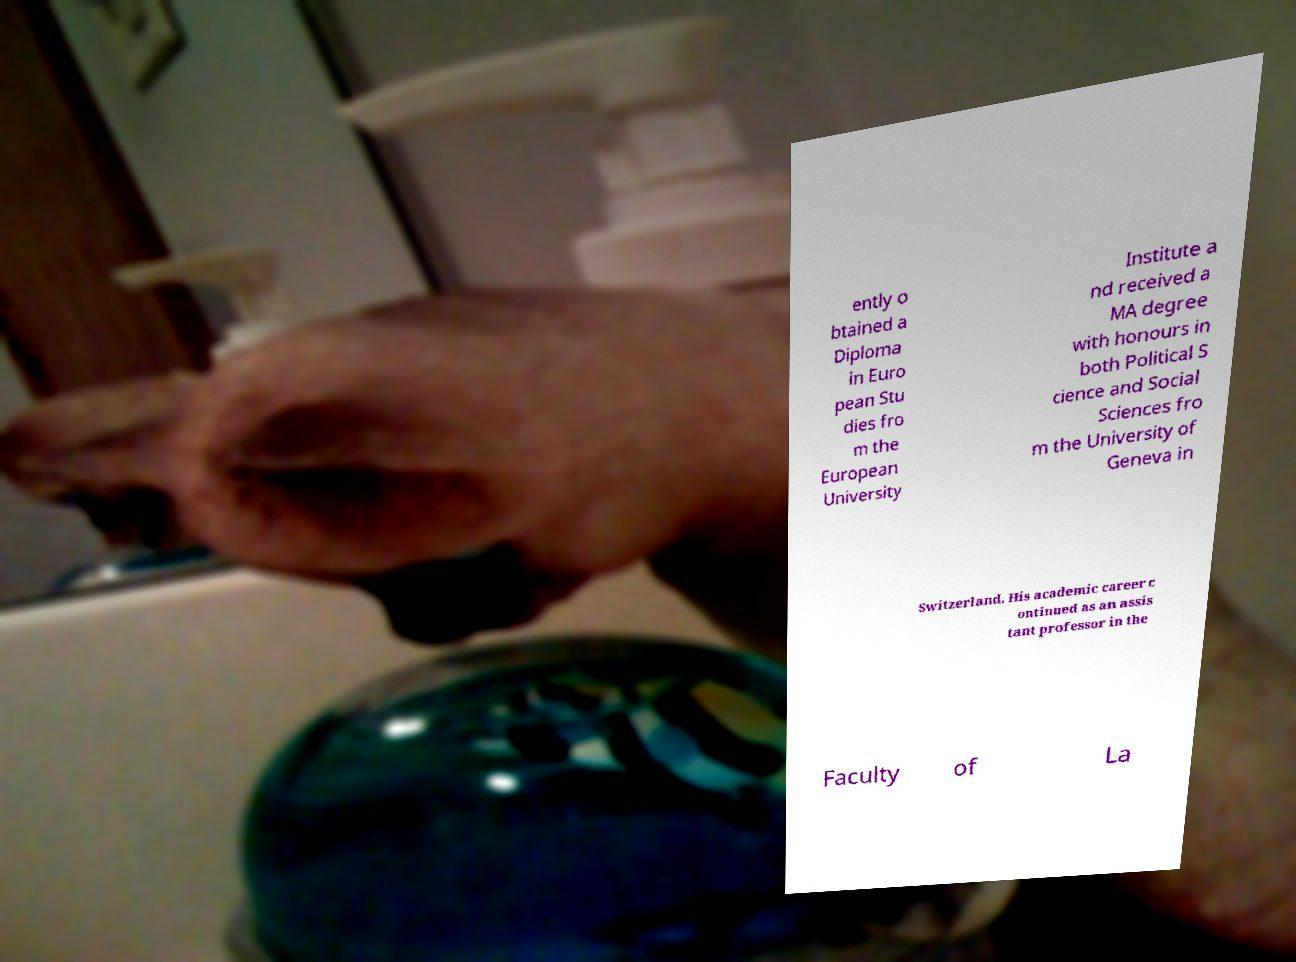Please identify and transcribe the text found in this image. ently o btained a Diploma in Euro pean Stu dies fro m the European University Institute a nd received a MA degree with honours in both Political S cience and Social Sciences fro m the University of Geneva in Switzerland. His academic career c ontinued as an assis tant professor in the Faculty of La 